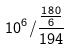Convert formula to latex. <formula><loc_0><loc_0><loc_500><loc_500>1 0 ^ { 6 } / \frac { \frac { 1 8 0 } { 6 } } { 1 9 4 }</formula> 